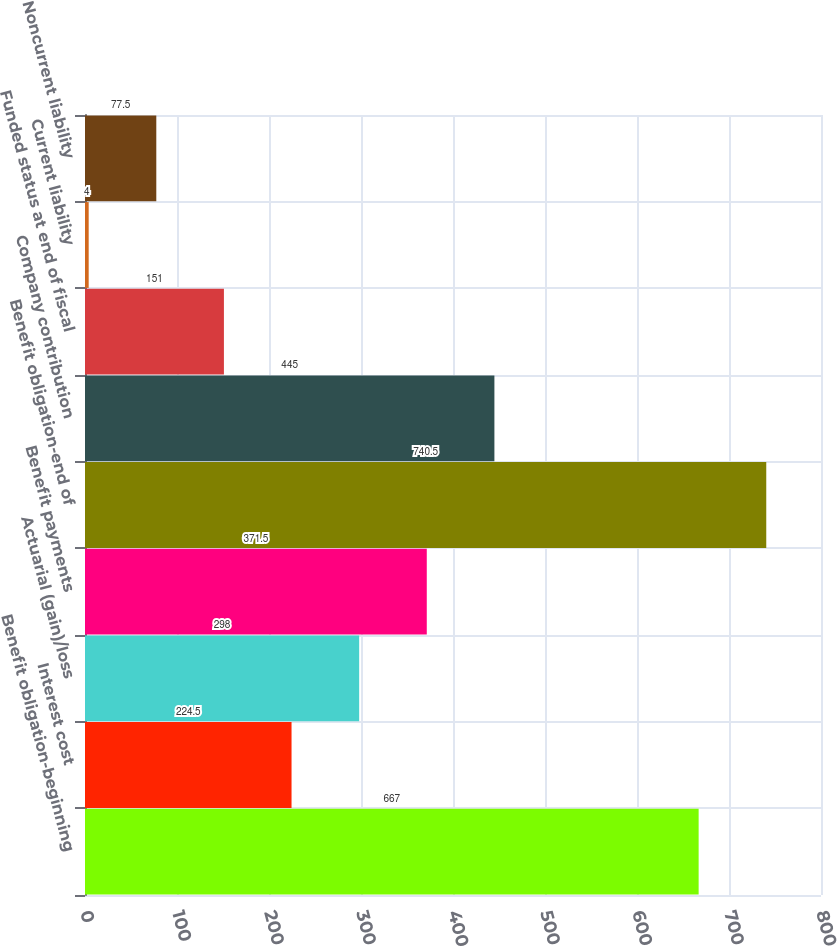Convert chart to OTSL. <chart><loc_0><loc_0><loc_500><loc_500><bar_chart><fcel>Benefit obligation-beginning<fcel>Interest cost<fcel>Actuarial (gain)/loss<fcel>Benefit payments<fcel>Benefit obligation-end of<fcel>Company contribution<fcel>Funded status at end of fiscal<fcel>Current liability<fcel>Noncurrent liability<nl><fcel>667<fcel>224.5<fcel>298<fcel>371.5<fcel>740.5<fcel>445<fcel>151<fcel>4<fcel>77.5<nl></chart> 